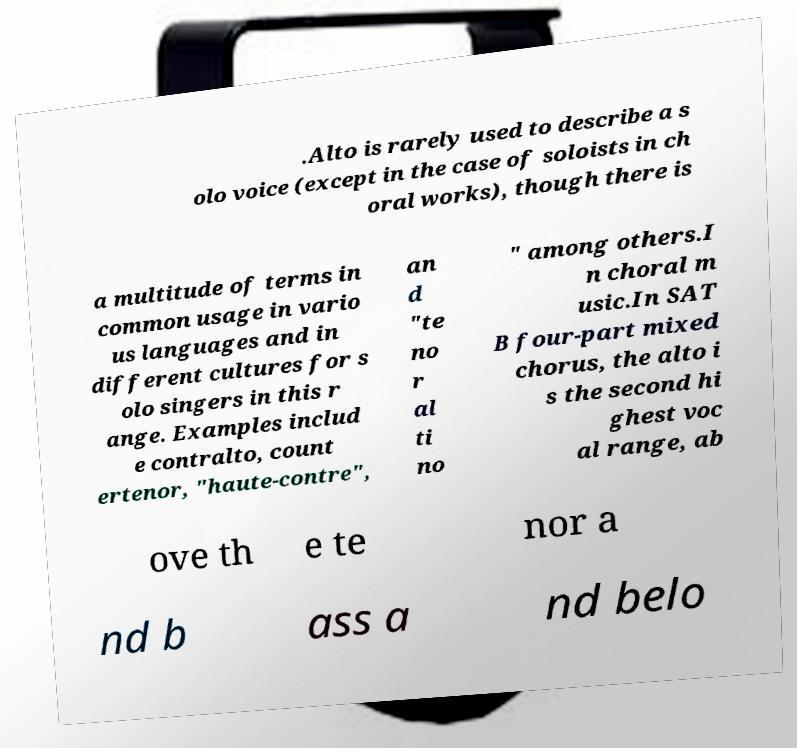What messages or text are displayed in this image? I need them in a readable, typed format. .Alto is rarely used to describe a s olo voice (except in the case of soloists in ch oral works), though there is a multitude of terms in common usage in vario us languages and in different cultures for s olo singers in this r ange. Examples includ e contralto, count ertenor, "haute-contre", an d "te no r al ti no " among others.I n choral m usic.In SAT B four-part mixed chorus, the alto i s the second hi ghest voc al range, ab ove th e te nor a nd b ass a nd belo 